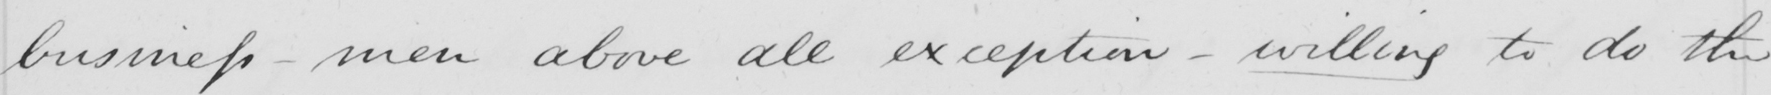Can you tell me what this handwritten text says? business  _  men above all exception  _  willing to do the 